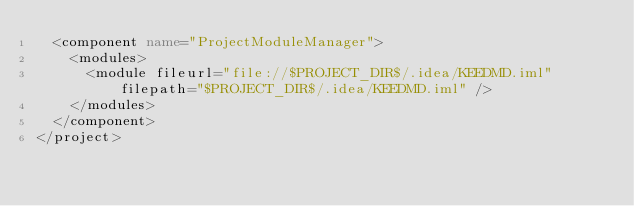<code> <loc_0><loc_0><loc_500><loc_500><_XML_>  <component name="ProjectModuleManager">
    <modules>
      <module fileurl="file://$PROJECT_DIR$/.idea/KEEDMD.iml" filepath="$PROJECT_DIR$/.idea/KEEDMD.iml" />
    </modules>
  </component>
</project></code> 